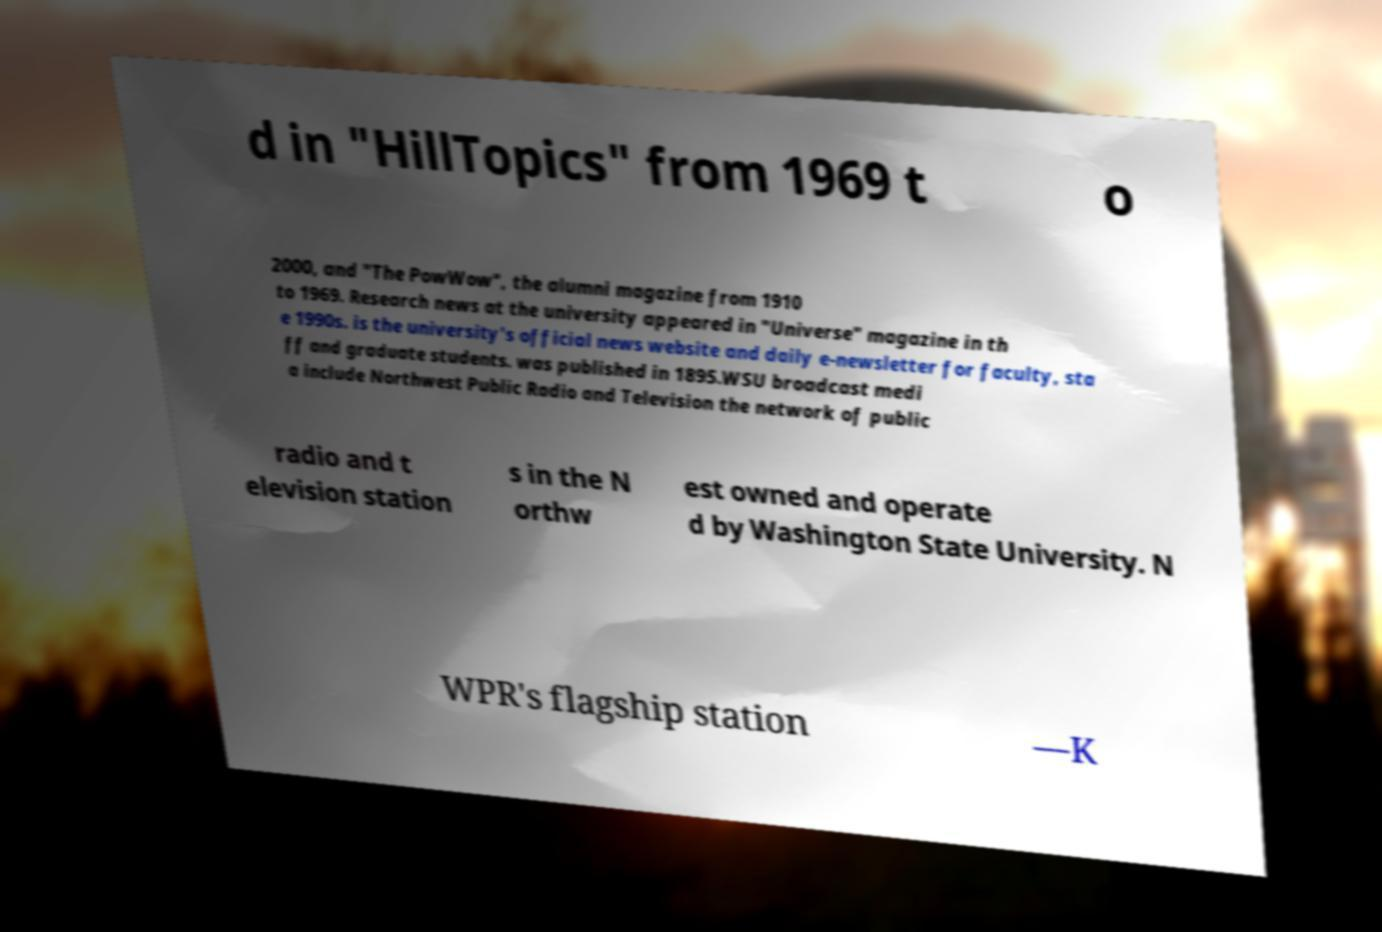There's text embedded in this image that I need extracted. Can you transcribe it verbatim? d in "HillTopics" from 1969 t o 2000, and "The PowWow", the alumni magazine from 1910 to 1969. Research news at the university appeared in "Universe" magazine in th e 1990s. is the university's official news website and daily e-newsletter for faculty, sta ff and graduate students. was published in 1895.WSU broadcast medi a include Northwest Public Radio and Television the network of public radio and t elevision station s in the N orthw est owned and operate d by Washington State University. N WPR's flagship station —K 